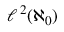<formula> <loc_0><loc_0><loc_500><loc_500>\ell ^ { \, 2 } ( \aleph _ { 0 } )</formula> 